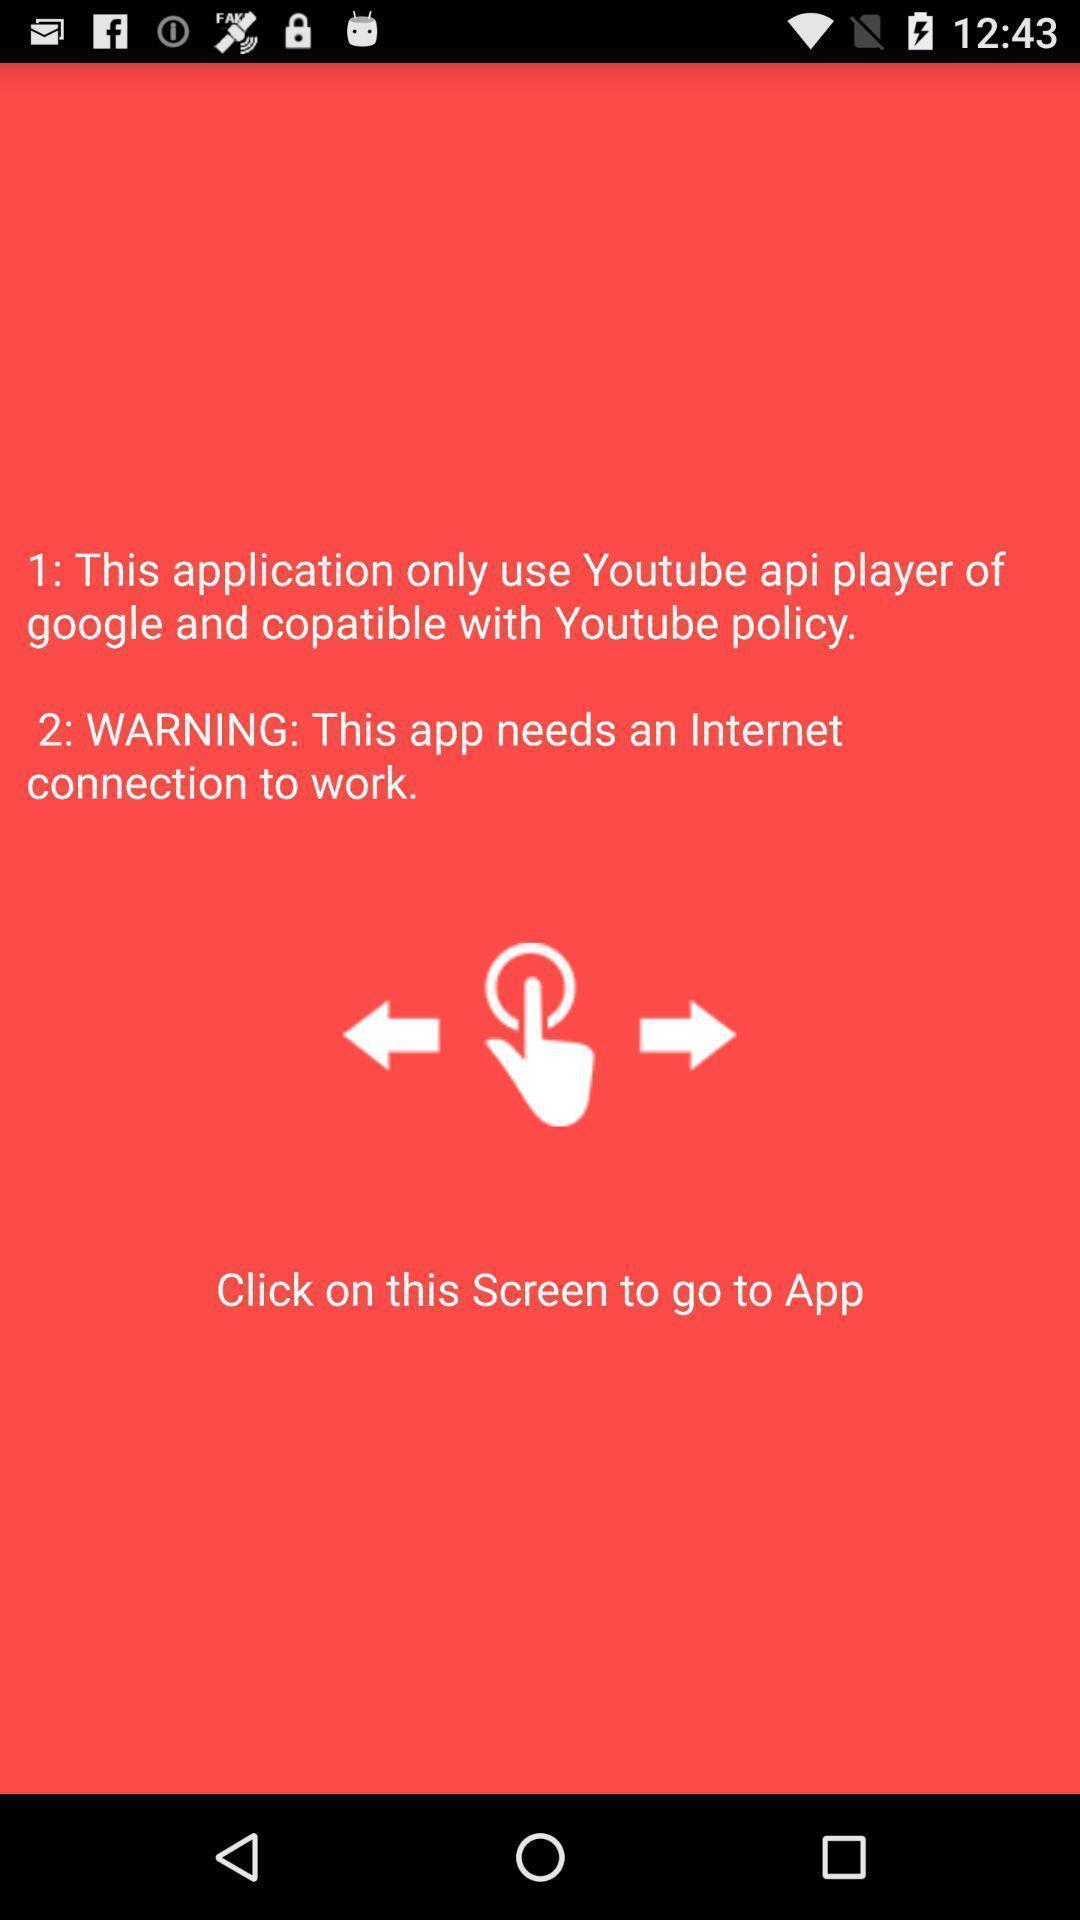What details can you identify in this image? Welcome page for a social application. 